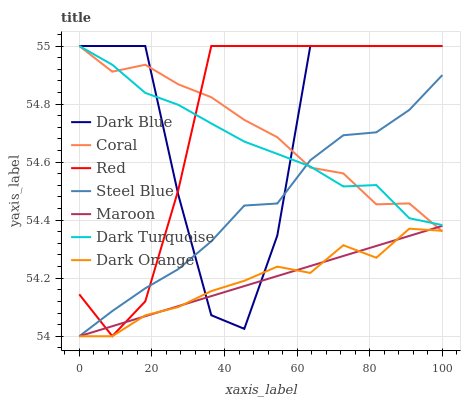Does Dark Turquoise have the minimum area under the curve?
Answer yes or no. No. Does Dark Turquoise have the maximum area under the curve?
Answer yes or no. No. Is Dark Turquoise the smoothest?
Answer yes or no. No. Is Dark Turquoise the roughest?
Answer yes or no. No. Does Coral have the lowest value?
Answer yes or no. No. Does Steel Blue have the highest value?
Answer yes or no. No. Is Dark Orange less than Red?
Answer yes or no. Yes. Is Dark Turquoise greater than Maroon?
Answer yes or no. Yes. Does Dark Orange intersect Red?
Answer yes or no. No. 